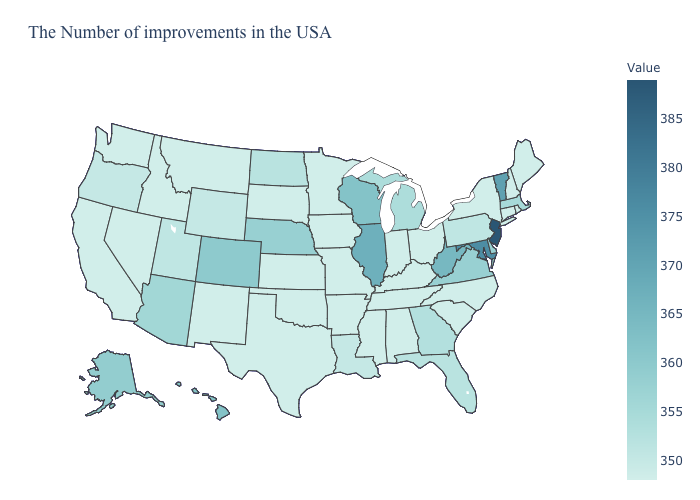Does New Hampshire have the highest value in the Northeast?
Concise answer only. No. Among the states that border New Jersey , which have the lowest value?
Write a very short answer. New York. Does Maryland have the highest value in the South?
Give a very brief answer. Yes. Among the states that border Nevada , which have the lowest value?
Write a very short answer. Idaho, California. Is the legend a continuous bar?
Keep it brief. Yes. 